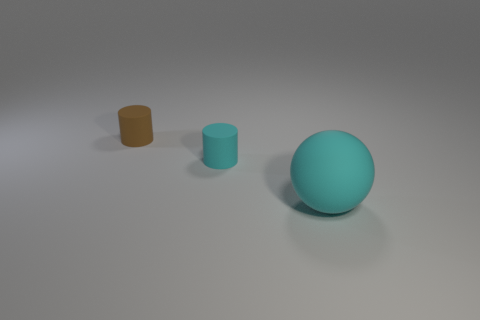How many other things are the same shape as the small cyan rubber thing?
Make the answer very short. 1. Is the number of tiny rubber objects to the right of the tiny brown cylinder the same as the number of matte cylinders in front of the big cyan matte object?
Provide a succinct answer. No. What is the material of the large sphere?
Your response must be concise. Rubber. What is the tiny cyan cylinder in front of the small brown matte cylinder made of?
Provide a succinct answer. Rubber. Are there more cyan cylinders behind the large cyan matte object than big brown rubber cylinders?
Offer a very short reply. Yes. Is there a large cyan rubber object left of the tiny cylinder that is on the left side of the cyan rubber thing behind the large rubber ball?
Your answer should be very brief. No. There is a tiny brown thing; are there any cyan spheres left of it?
Offer a terse response. No. What number of matte things have the same color as the rubber ball?
Make the answer very short. 1. The brown cylinder that is the same material as the ball is what size?
Give a very brief answer. Small. There is a thing on the right side of the cyan object that is to the left of the thing that is in front of the cyan cylinder; how big is it?
Provide a succinct answer. Large. 